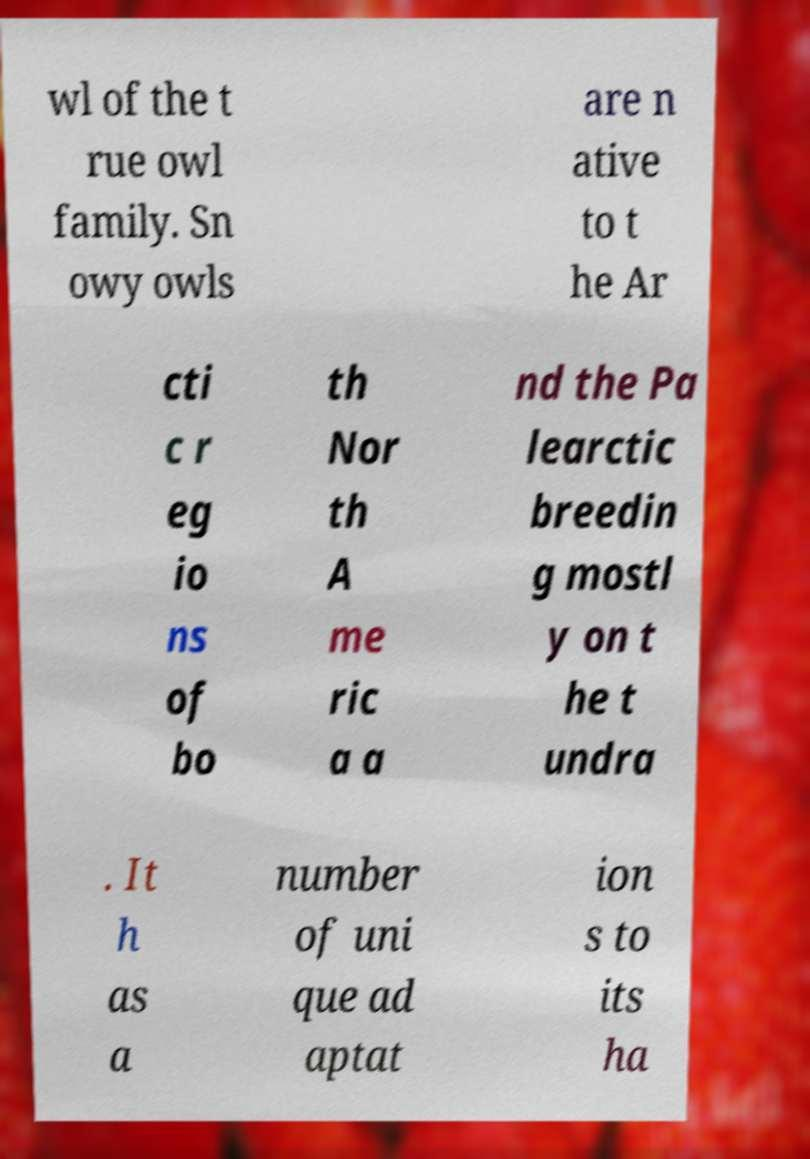Please identify and transcribe the text found in this image. wl of the t rue owl family. Sn owy owls are n ative to t he Ar cti c r eg io ns of bo th Nor th A me ric a a nd the Pa learctic breedin g mostl y on t he t undra . It h as a number of uni que ad aptat ion s to its ha 